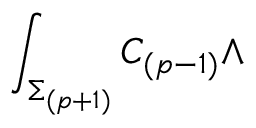<formula> <loc_0><loc_0><loc_500><loc_500>\int _ { \Sigma _ { ( p + 1 ) } } C _ { ( p - 1 ) } \wedge</formula> 